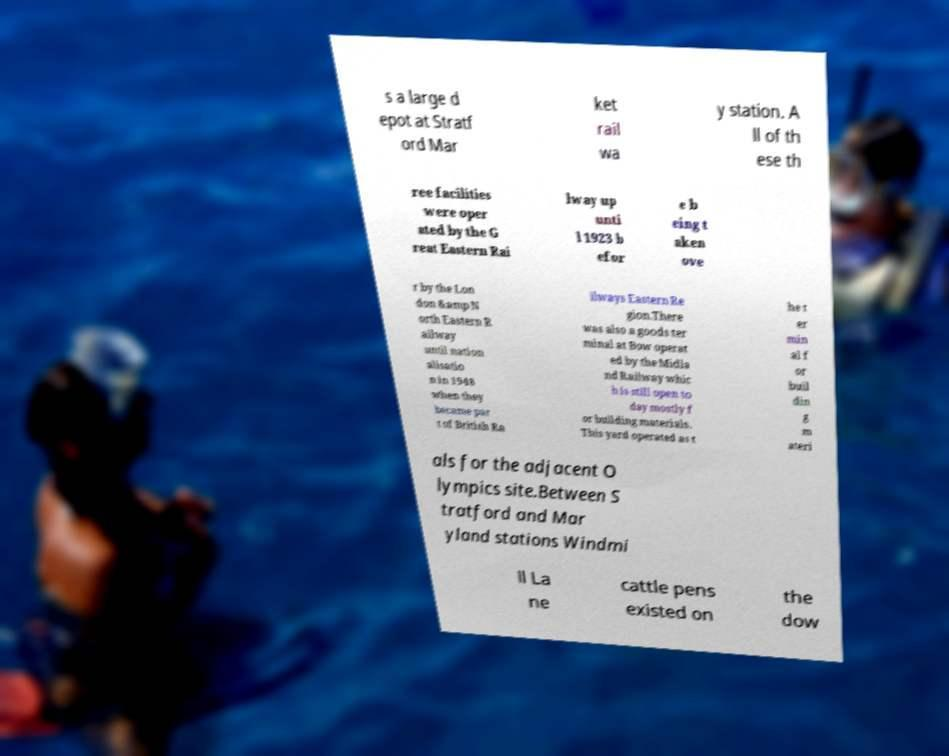There's text embedded in this image that I need extracted. Can you transcribe it verbatim? s a large d epot at Stratf ord Mar ket rail wa y station. A ll of th ese th ree facilities were oper ated by the G reat Eastern Rai lway up unti l 1923 b efor e b eing t aken ove r by the Lon don &amp N orth Eastern R ailway until nation alisatio n in 1948 when they became par t of British Ra ilways Eastern Re gion.There was also a goods ter minal at Bow operat ed by the Midla nd Railway whic h is still open to day mostly f or building materials. This yard operated as t he t er min al f or buil din g m ateri als for the adjacent O lympics site.Between S tratford and Mar yland stations Windmi ll La ne cattle pens existed on the dow 